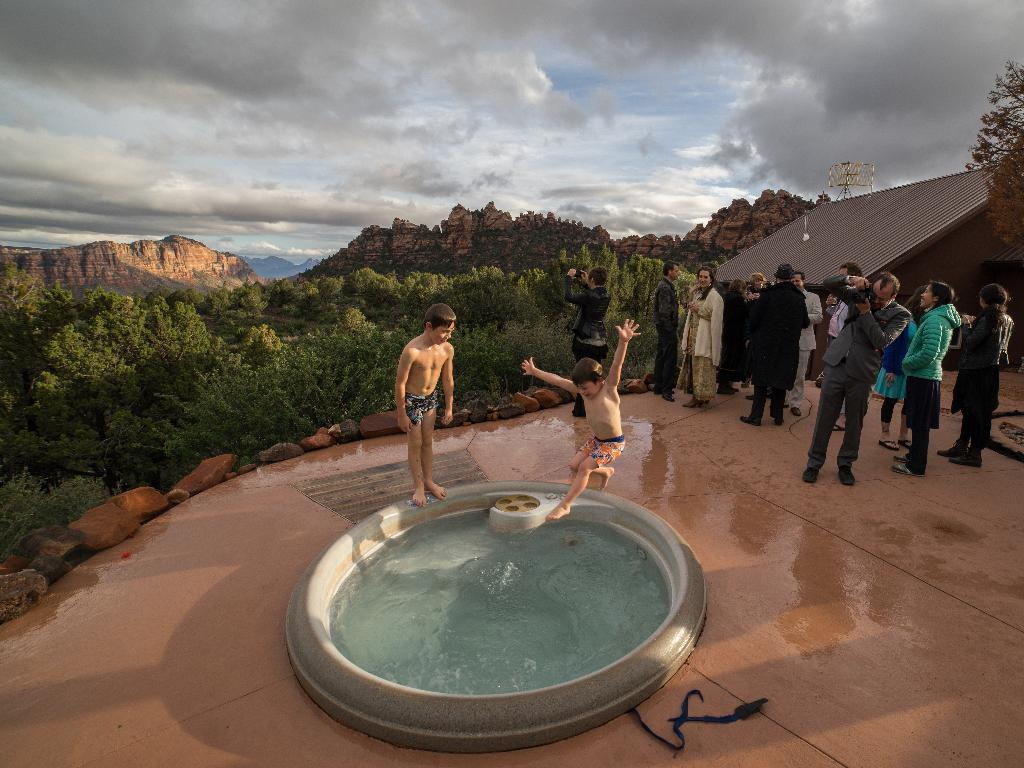What is located in the foreground of the image? There is a pool in the foreground of the image. What are the two boys in the image doing? The two boys are jumping into the pool. What can be seen in the background of the image? There are people standing, a building, trees, mountains, and the sky visible in the background of the image. Can you describe the sky in the image? The sky is visible in the background of the image, and there is a cloud present. What type of writing can be seen on the pipe in the image? There is no pipe present in the image, so no writing can be observed. 